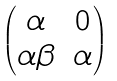Convert formula to latex. <formula><loc_0><loc_0><loc_500><loc_500>\begin{pmatrix} \alpha & 0 \\ \alpha \beta & \alpha \end{pmatrix}</formula> 